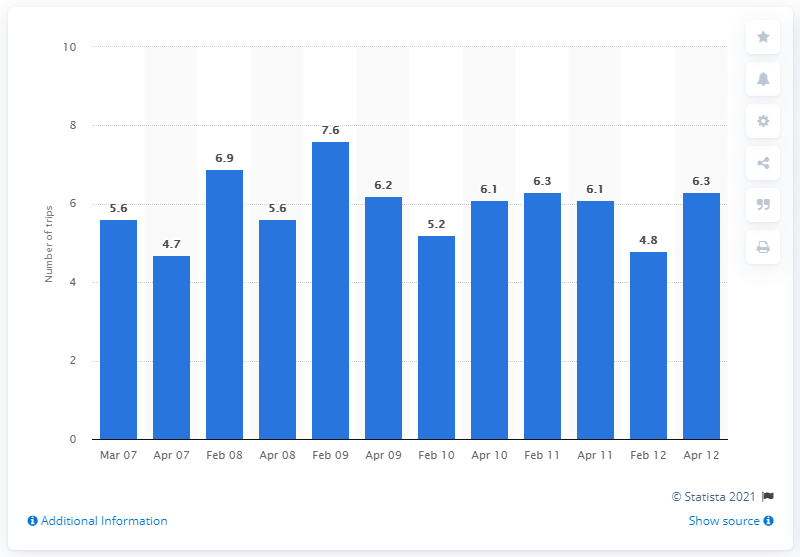Indicate a few pertinent items in this graphic. In March 2007, the average number of business trips taken by adults in the U.S. was 5.6. 